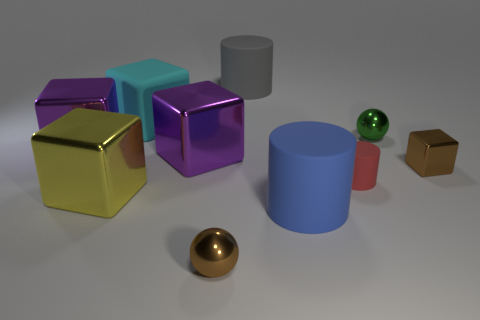Subtract all blue cylinders. How many cylinders are left? 2 Subtract all brown balls. How many balls are left? 1 Subtract all cylinders. How many objects are left? 7 Subtract 4 blocks. How many blocks are left? 1 Subtract all cyan cylinders. How many brown spheres are left? 1 Subtract all blue cylinders. Subtract all small red objects. How many objects are left? 8 Add 6 big shiny things. How many big shiny things are left? 9 Add 4 small yellow cylinders. How many small yellow cylinders exist? 4 Subtract 0 blue spheres. How many objects are left? 10 Subtract all green blocks. Subtract all yellow balls. How many blocks are left? 5 